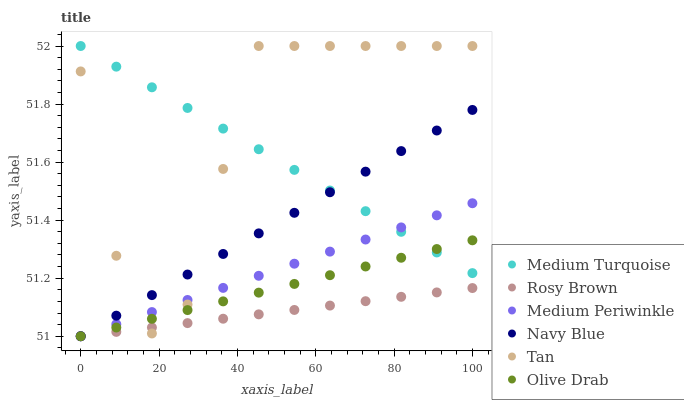Does Rosy Brown have the minimum area under the curve?
Answer yes or no. Yes. Does Tan have the maximum area under the curve?
Answer yes or no. Yes. Does Medium Periwinkle have the minimum area under the curve?
Answer yes or no. No. Does Medium Periwinkle have the maximum area under the curve?
Answer yes or no. No. Is Navy Blue the smoothest?
Answer yes or no. Yes. Is Tan the roughest?
Answer yes or no. Yes. Is Rosy Brown the smoothest?
Answer yes or no. No. Is Rosy Brown the roughest?
Answer yes or no. No. Does Navy Blue have the lowest value?
Answer yes or no. Yes. Does Medium Turquoise have the lowest value?
Answer yes or no. No. Does Tan have the highest value?
Answer yes or no. Yes. Does Medium Periwinkle have the highest value?
Answer yes or no. No. Is Rosy Brown less than Medium Turquoise?
Answer yes or no. Yes. Is Medium Turquoise greater than Rosy Brown?
Answer yes or no. Yes. Does Navy Blue intersect Medium Periwinkle?
Answer yes or no. Yes. Is Navy Blue less than Medium Periwinkle?
Answer yes or no. No. Is Navy Blue greater than Medium Periwinkle?
Answer yes or no. No. Does Rosy Brown intersect Medium Turquoise?
Answer yes or no. No. 